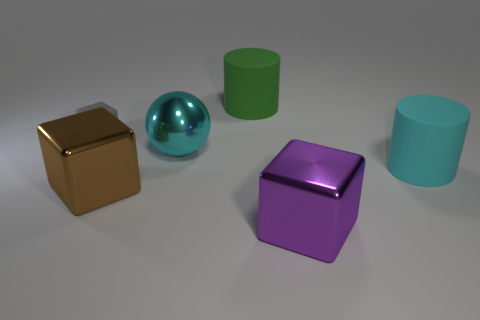What number of spheres are either small red shiny objects or brown things?
Make the answer very short. 0. How many large green objects are there?
Provide a succinct answer. 1. There is a large green matte object; is it the same shape as the large rubber object that is in front of the large green matte cylinder?
Your response must be concise. Yes. What size is the rubber cylinder that is the same color as the metallic ball?
Your answer should be compact. Large. What number of things are gray rubber cubes or large gray rubber spheres?
Your answer should be very brief. 1. What is the shape of the cyan thing left of the cyan object in front of the cyan shiny thing?
Provide a short and direct response. Sphere. There is a matte object that is on the left side of the green cylinder; is its shape the same as the big green thing?
Provide a succinct answer. No. What is the size of the brown thing that is made of the same material as the big purple block?
Keep it short and to the point. Large. How many objects are rubber cylinders left of the large purple shiny thing or cubes that are in front of the large cyan metal object?
Your answer should be compact. 3. Are there the same number of big shiny cubes on the left side of the purple block and small gray rubber things that are to the left of the gray thing?
Offer a terse response. No. 